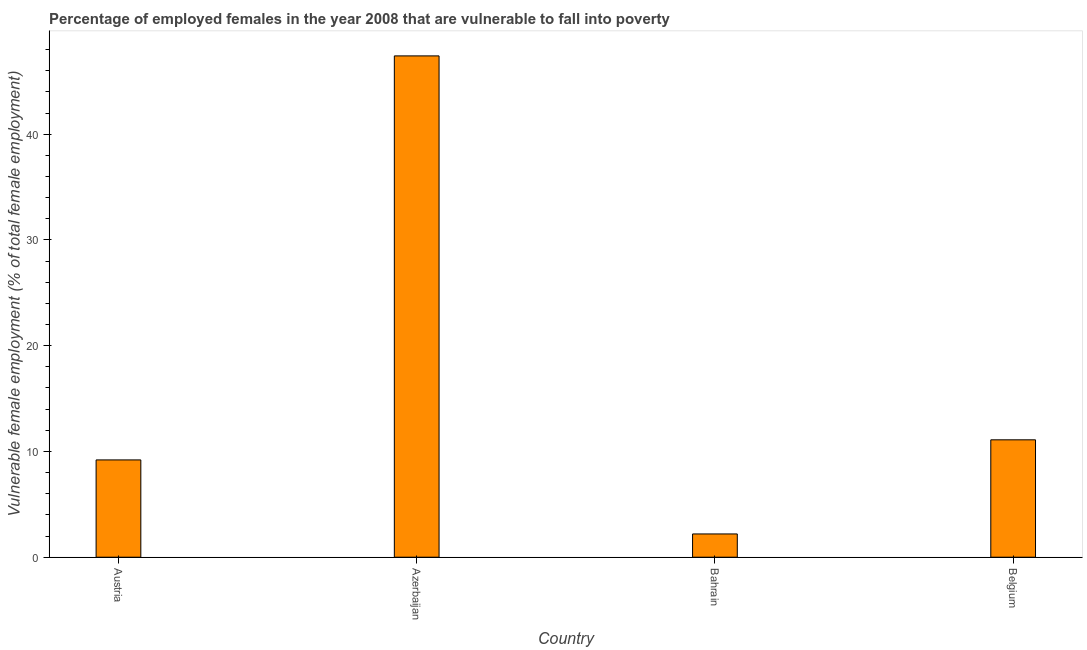Does the graph contain grids?
Your response must be concise. No. What is the title of the graph?
Your response must be concise. Percentage of employed females in the year 2008 that are vulnerable to fall into poverty. What is the label or title of the X-axis?
Your response must be concise. Country. What is the label or title of the Y-axis?
Provide a succinct answer. Vulnerable female employment (% of total female employment). What is the percentage of employed females who are vulnerable to fall into poverty in Belgium?
Offer a terse response. 11.1. Across all countries, what is the maximum percentage of employed females who are vulnerable to fall into poverty?
Your response must be concise. 47.4. Across all countries, what is the minimum percentage of employed females who are vulnerable to fall into poverty?
Keep it short and to the point. 2.2. In which country was the percentage of employed females who are vulnerable to fall into poverty maximum?
Your answer should be very brief. Azerbaijan. In which country was the percentage of employed females who are vulnerable to fall into poverty minimum?
Your answer should be compact. Bahrain. What is the sum of the percentage of employed females who are vulnerable to fall into poverty?
Ensure brevity in your answer.  69.9. What is the difference between the percentage of employed females who are vulnerable to fall into poverty in Azerbaijan and Bahrain?
Offer a very short reply. 45.2. What is the average percentage of employed females who are vulnerable to fall into poverty per country?
Your answer should be compact. 17.48. What is the median percentage of employed females who are vulnerable to fall into poverty?
Provide a succinct answer. 10.15. What is the ratio of the percentage of employed females who are vulnerable to fall into poverty in Austria to that in Belgium?
Offer a terse response. 0.83. Is the percentage of employed females who are vulnerable to fall into poverty in Austria less than that in Belgium?
Keep it short and to the point. Yes. Is the difference between the percentage of employed females who are vulnerable to fall into poverty in Azerbaijan and Belgium greater than the difference between any two countries?
Ensure brevity in your answer.  No. What is the difference between the highest and the second highest percentage of employed females who are vulnerable to fall into poverty?
Offer a very short reply. 36.3. Is the sum of the percentage of employed females who are vulnerable to fall into poverty in Bahrain and Belgium greater than the maximum percentage of employed females who are vulnerable to fall into poverty across all countries?
Provide a short and direct response. No. What is the difference between the highest and the lowest percentage of employed females who are vulnerable to fall into poverty?
Your answer should be compact. 45.2. How many bars are there?
Provide a succinct answer. 4. What is the Vulnerable female employment (% of total female employment) of Austria?
Provide a succinct answer. 9.2. What is the Vulnerable female employment (% of total female employment) in Azerbaijan?
Give a very brief answer. 47.4. What is the Vulnerable female employment (% of total female employment) in Bahrain?
Offer a very short reply. 2.2. What is the Vulnerable female employment (% of total female employment) in Belgium?
Offer a very short reply. 11.1. What is the difference between the Vulnerable female employment (% of total female employment) in Austria and Azerbaijan?
Provide a succinct answer. -38.2. What is the difference between the Vulnerable female employment (% of total female employment) in Austria and Bahrain?
Provide a short and direct response. 7. What is the difference between the Vulnerable female employment (% of total female employment) in Austria and Belgium?
Offer a very short reply. -1.9. What is the difference between the Vulnerable female employment (% of total female employment) in Azerbaijan and Bahrain?
Make the answer very short. 45.2. What is the difference between the Vulnerable female employment (% of total female employment) in Azerbaijan and Belgium?
Offer a terse response. 36.3. What is the ratio of the Vulnerable female employment (% of total female employment) in Austria to that in Azerbaijan?
Your answer should be very brief. 0.19. What is the ratio of the Vulnerable female employment (% of total female employment) in Austria to that in Bahrain?
Give a very brief answer. 4.18. What is the ratio of the Vulnerable female employment (% of total female employment) in Austria to that in Belgium?
Offer a terse response. 0.83. What is the ratio of the Vulnerable female employment (% of total female employment) in Azerbaijan to that in Bahrain?
Provide a succinct answer. 21.55. What is the ratio of the Vulnerable female employment (% of total female employment) in Azerbaijan to that in Belgium?
Provide a succinct answer. 4.27. What is the ratio of the Vulnerable female employment (% of total female employment) in Bahrain to that in Belgium?
Provide a succinct answer. 0.2. 